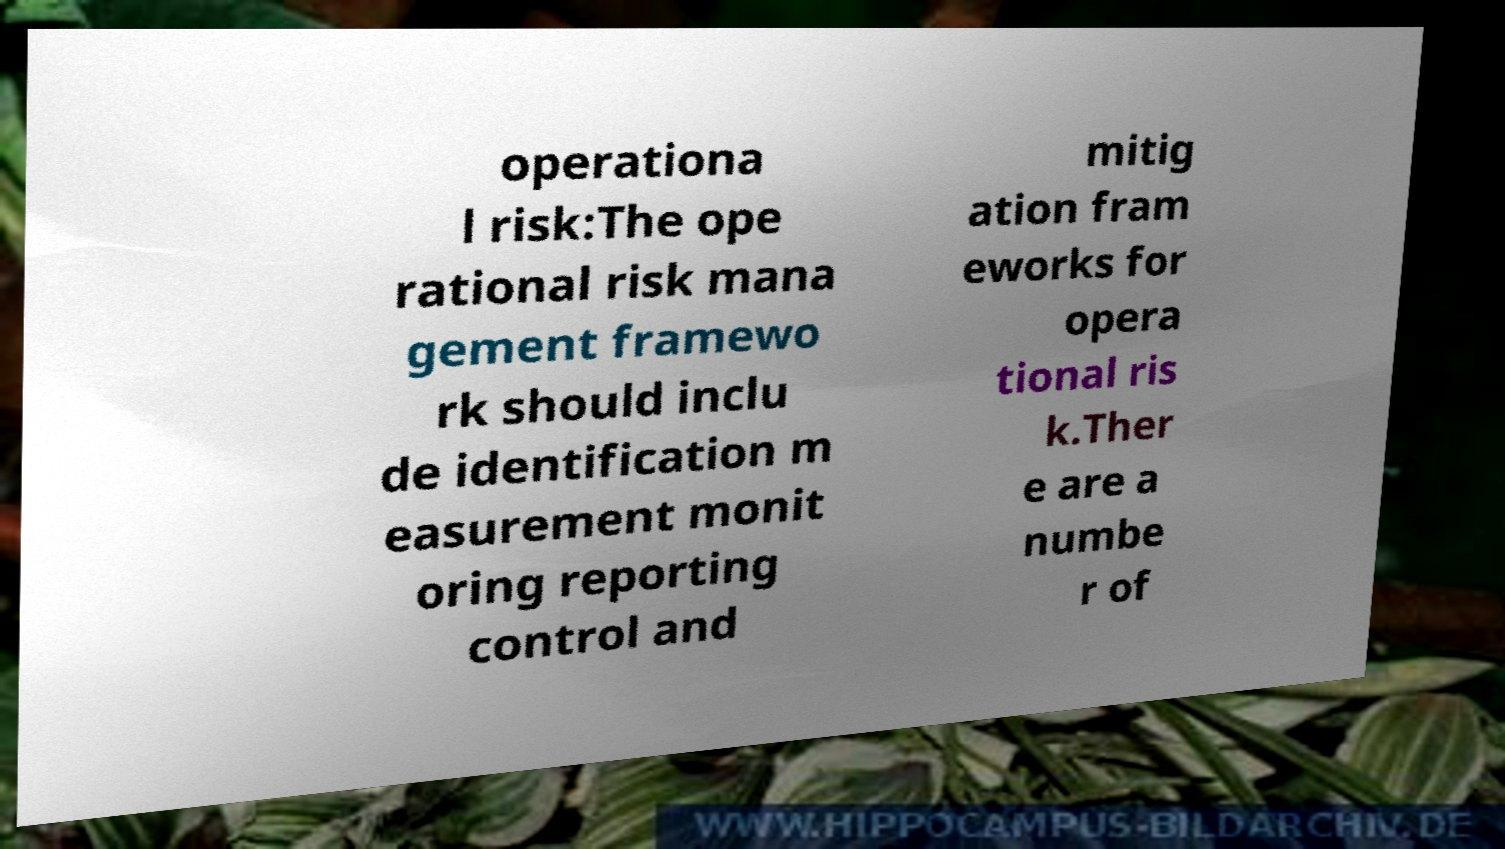Can you accurately transcribe the text from the provided image for me? operationa l risk:The ope rational risk mana gement framewo rk should inclu de identification m easurement monit oring reporting control and mitig ation fram eworks for opera tional ris k.Ther e are a numbe r of 